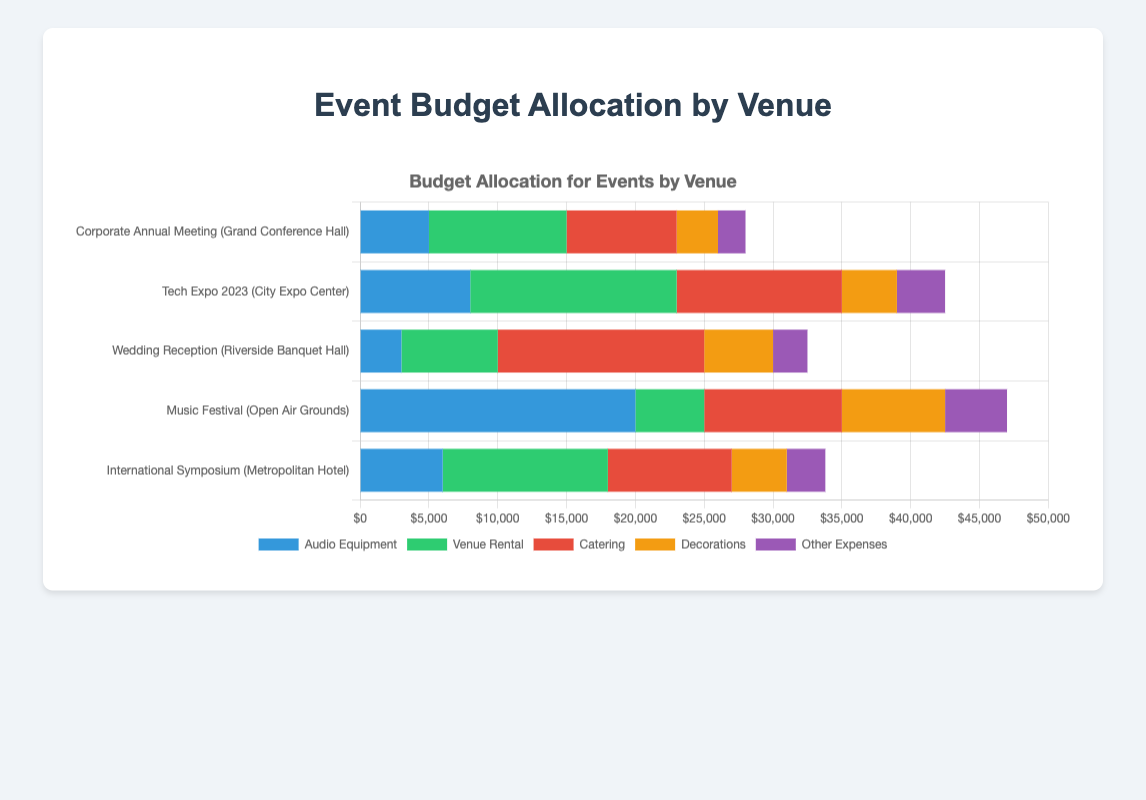How does the budget allocation for audio equipment compare between the Music Festival and Corporate Annual Meeting? The Music Festival has a higher budget allocation for audio equipment (20,000) compared to the Corporate Annual Meeting (5,000).
Answer: Music Festival has a higher budget Which event has the smallest allocation for venue rental? By looking at the lengths of the green bars representing venue rental costs, the Music Festival at the Open Air Grounds has the smallest allocation of 5,000.
Answer: Music Festival For the Tech Expo 2023, what is the total budget allocation for non-audio expenses? Summing the budget allocations for venue rental (15,000), catering (12,000), decorations (4,000), and other expenses (3,500), the total is 34,500.
Answer: 34,500 Which event has the highest total budget allocation across all categories? By visually comparing the total lengths of the stacked bars for each event, the Tech Expo 2023 at City Expo Center has the highest total budget.
Answer: Tech Expo 2023 What is the difference in the catering budget between the Wedding Reception and International Symposium? The catering budget for the Wedding Reception is 15,000, while for the International Symposium, it is 9,000. The difference is 6,000.
Answer: 6,000 Which event has a larger proportion of its budget allocated to decorations, the Corporate Annual Meeting or the Tech Expo 2023? To determine the proportions, compare the length of the orange decoration bars relative to the total bar length for each event. The Corporate Annual Meeting has a smaller proportion compared to Tech Expo 2023.
Answer: Tech Expo 2023 What is the approximate combined budget for audio equipment across all events? Summing the budget allocations for audio equipment: 5,000 (Corporate Annual Meeting) + 8,000 (Tech Expo 2023) + 3,000 (Wedding Reception) + 20,000 (Music Festival) + 6,000 (International Symposium) gives a total of 42,000.
Answer: 42,000 By how much does the catering budget for the Wedding Reception surpass the catering budget for the Music Festival? The catering budget for the Wedding Reception is 15,000 and for the Music Festival is 10,000. The difference is 5,000.
Answer: 5,000 Identify the event with the least allocation for other expenses and state the amount. The Corporate Annual Meeting has the least allocation for other expenses, with an amount of 2,000, as indicated by the shortest purple bar.
Answer: Corporate Annual Meeting, 2,000 